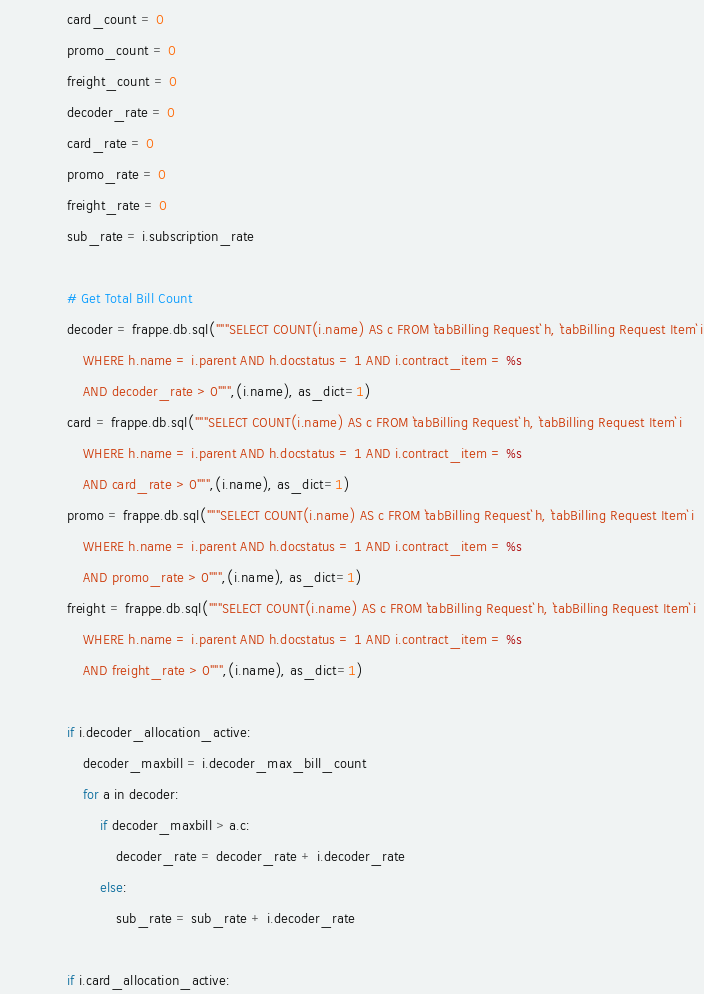<code> <loc_0><loc_0><loc_500><loc_500><_Python_>                card_count = 0
                promo_count = 0
                freight_count = 0
                decoder_rate = 0
                card_rate = 0
                promo_rate = 0
                freight_rate = 0
                sub_rate = i.subscription_rate

                # Get Total Bill Count
                decoder = frappe.db.sql("""SELECT COUNT(i.name) AS c FROM `tabBilling Request` h, `tabBilling Request Item` i
                    WHERE h.name = i.parent AND h.docstatus = 1 AND i.contract_item = %s 
                    AND decoder_rate > 0""",(i.name), as_dict=1)
                card = frappe.db.sql("""SELECT COUNT(i.name) AS c FROM `tabBilling Request` h, `tabBilling Request Item` i
                    WHERE h.name = i.parent AND h.docstatus = 1 AND i.contract_item = %s 
                    AND card_rate > 0""",(i.name), as_dict=1)
                promo = frappe.db.sql("""SELECT COUNT(i.name) AS c FROM `tabBilling Request` h, `tabBilling Request Item` i
                    WHERE h.name = i.parent AND h.docstatus = 1 AND i.contract_item = %s
                    AND promo_rate > 0""",(i.name), as_dict=1)
                freight = frappe.db.sql("""SELECT COUNT(i.name) AS c FROM `tabBilling Request` h, `tabBilling Request Item` i
                    WHERE h.name = i.parent AND h.docstatus = 1 AND i.contract_item = %s
                    AND freight_rate > 0""",(i.name), as_dict=1)

                if i.decoder_allocation_active:
                    decoder_maxbill = i.decoder_max_bill_count
                    for a in decoder:
                        if decoder_maxbill > a.c:
                            decoder_rate = decoder_rate + i.decoder_rate
                        else:
                            sub_rate = sub_rate + i.decoder_rate

                if i.card_allocation_active:</code> 